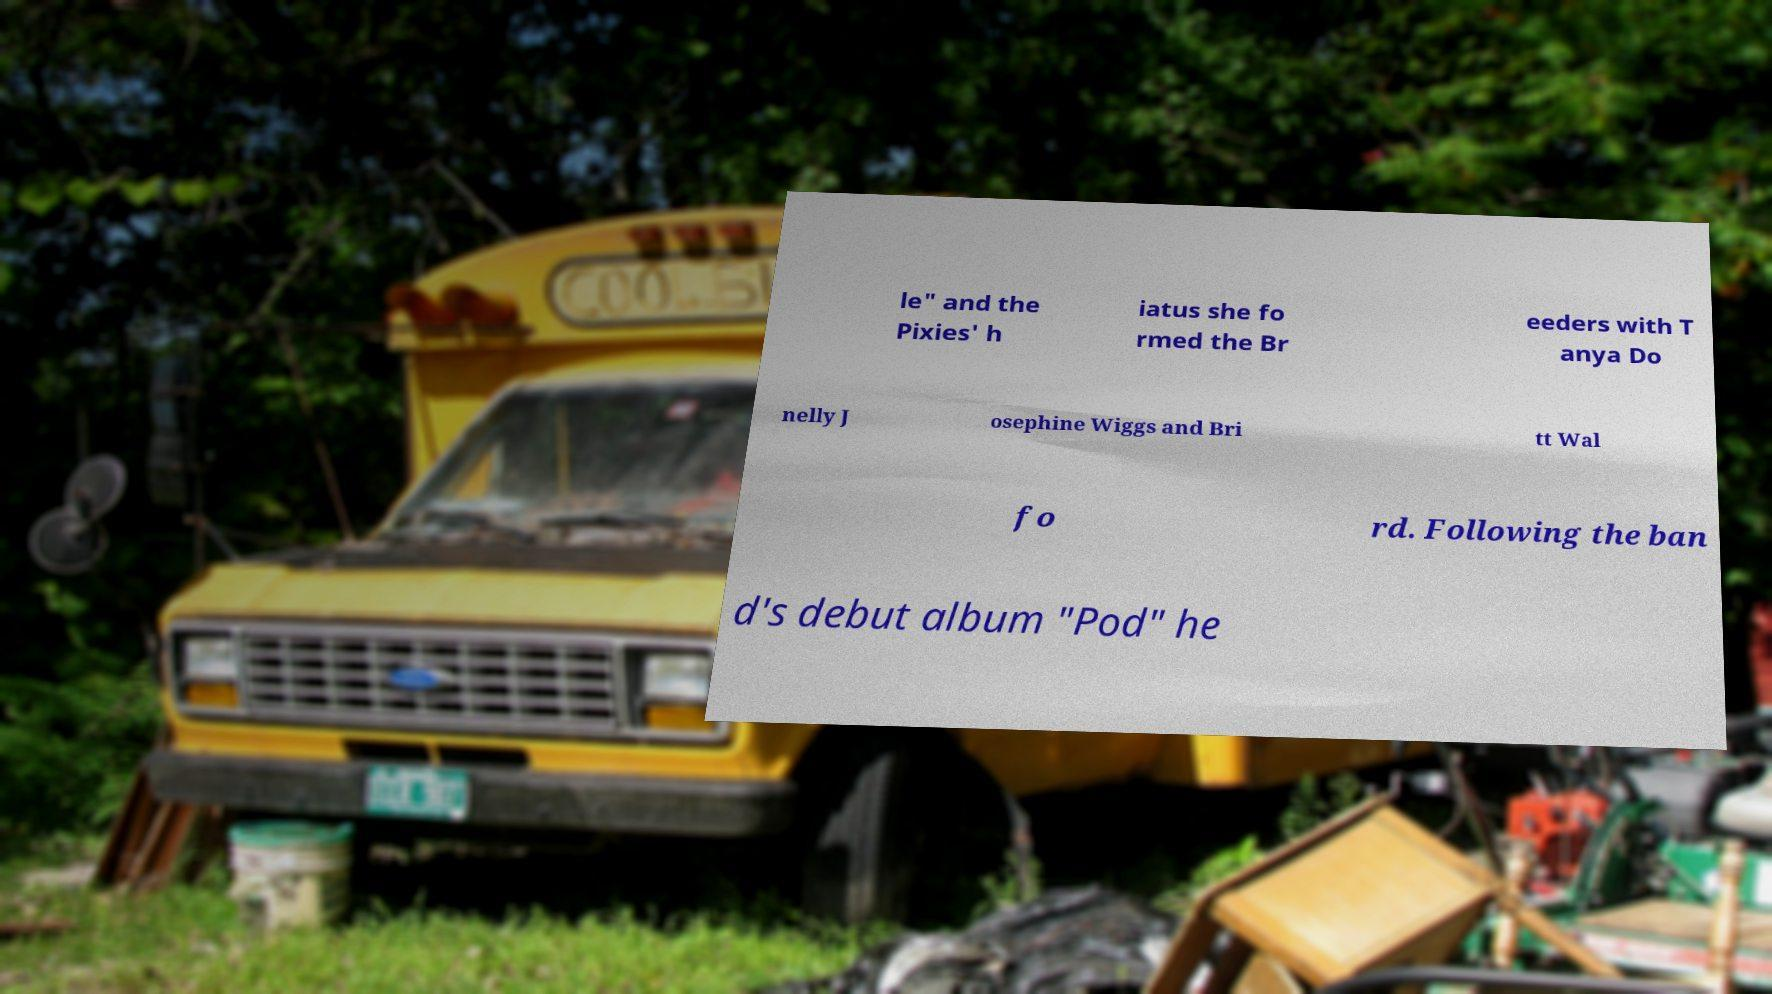Please read and relay the text visible in this image. What does it say? le" and the Pixies' h iatus she fo rmed the Br eeders with T anya Do nelly J osephine Wiggs and Bri tt Wal fo rd. Following the ban d's debut album "Pod" he 